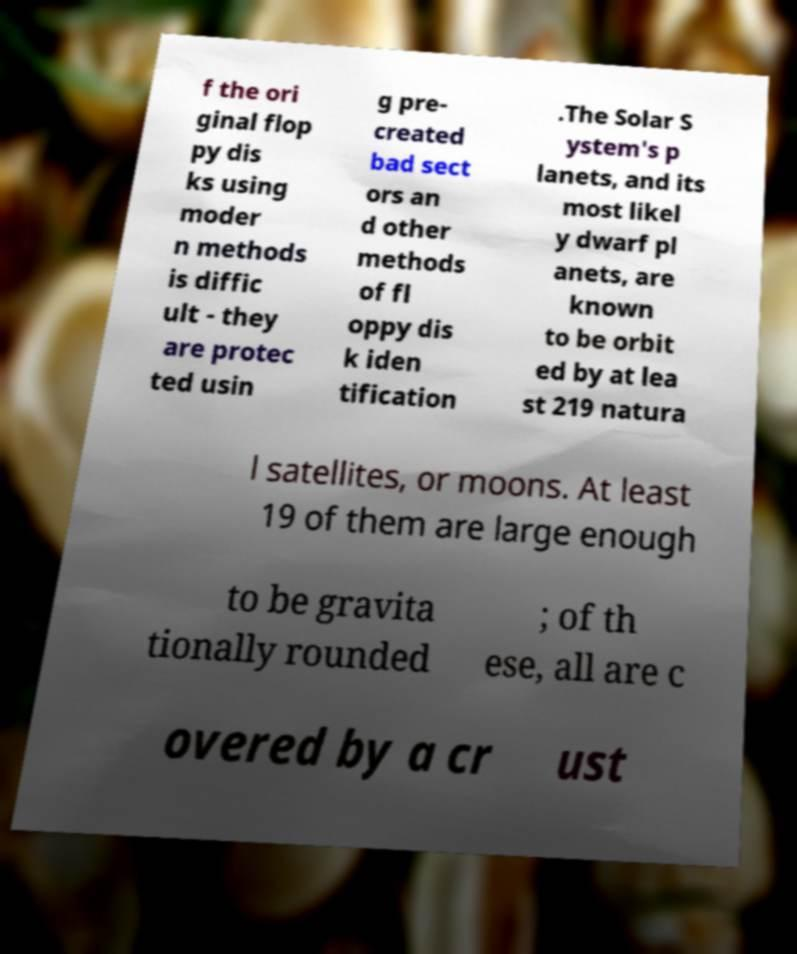What messages or text are displayed in this image? I need them in a readable, typed format. f the ori ginal flop py dis ks using moder n methods is diffic ult - they are protec ted usin g pre- created bad sect ors an d other methods of fl oppy dis k iden tification .The Solar S ystem's p lanets, and its most likel y dwarf pl anets, are known to be orbit ed by at lea st 219 natura l satellites, or moons. At least 19 of them are large enough to be gravita tionally rounded ; of th ese, all are c overed by a cr ust 